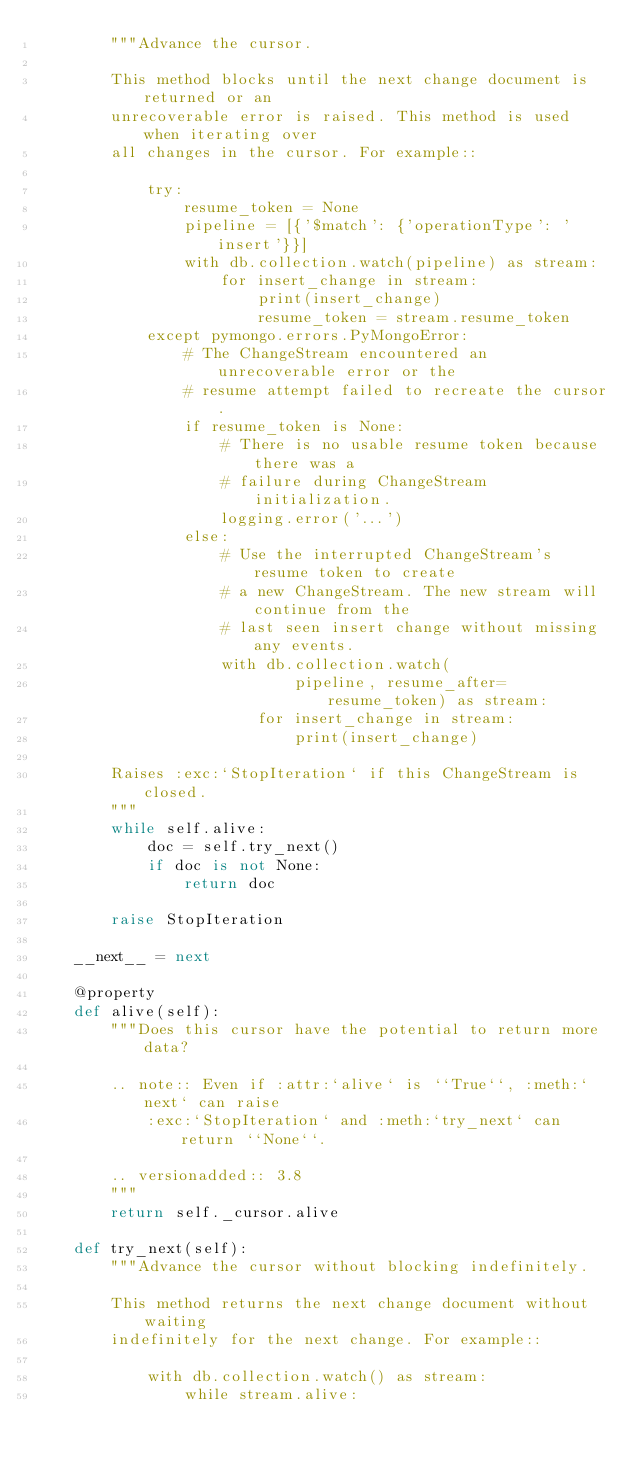<code> <loc_0><loc_0><loc_500><loc_500><_Python_>        """Advance the cursor.

        This method blocks until the next change document is returned or an
        unrecoverable error is raised. This method is used when iterating over
        all changes in the cursor. For example::

            try:
                resume_token = None
                pipeline = [{'$match': {'operationType': 'insert'}}]
                with db.collection.watch(pipeline) as stream:
                    for insert_change in stream:
                        print(insert_change)
                        resume_token = stream.resume_token
            except pymongo.errors.PyMongoError:
                # The ChangeStream encountered an unrecoverable error or the
                # resume attempt failed to recreate the cursor.
                if resume_token is None:
                    # There is no usable resume token because there was a
                    # failure during ChangeStream initialization.
                    logging.error('...')
                else:
                    # Use the interrupted ChangeStream's resume token to create
                    # a new ChangeStream. The new stream will continue from the
                    # last seen insert change without missing any events.
                    with db.collection.watch(
                            pipeline, resume_after=resume_token) as stream:
                        for insert_change in stream:
                            print(insert_change)

        Raises :exc:`StopIteration` if this ChangeStream is closed.
        """
        while self.alive:
            doc = self.try_next()
            if doc is not None:
                return doc

        raise StopIteration

    __next__ = next

    @property
    def alive(self):
        """Does this cursor have the potential to return more data?

        .. note:: Even if :attr:`alive` is ``True``, :meth:`next` can raise
            :exc:`StopIteration` and :meth:`try_next` can return ``None``.

        .. versionadded:: 3.8
        """
        return self._cursor.alive

    def try_next(self):
        """Advance the cursor without blocking indefinitely.

        This method returns the next change document without waiting
        indefinitely for the next change. For example::

            with db.collection.watch() as stream:
                while stream.alive:</code> 